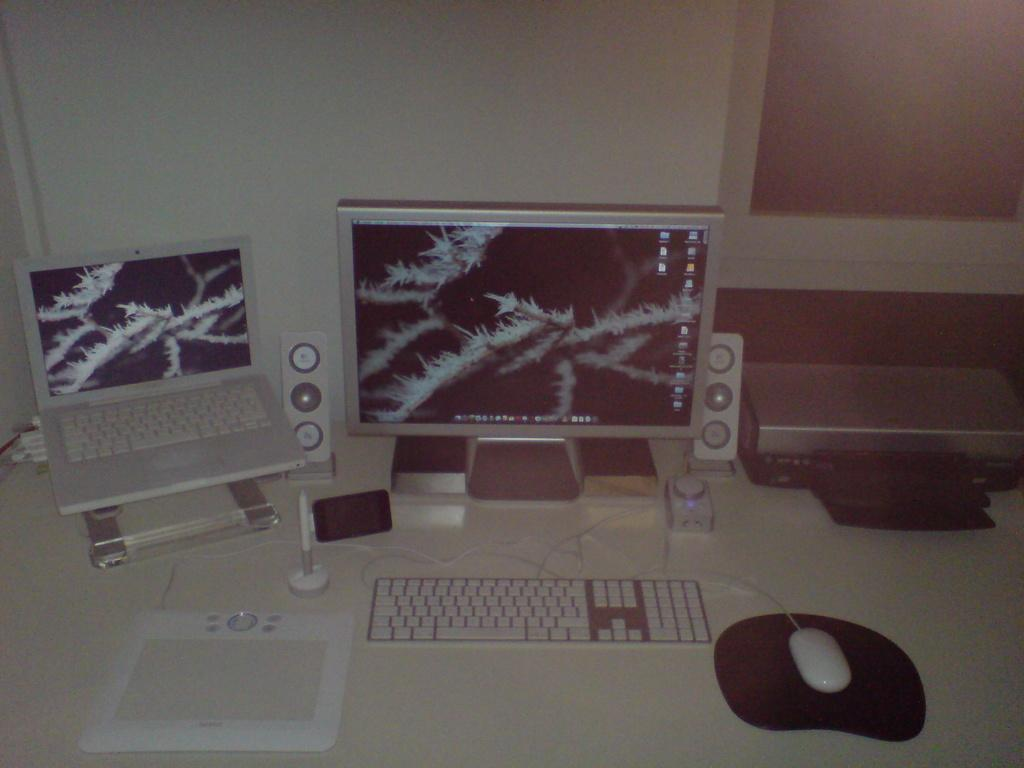What type of electronic device is visible in the image? There is a monitor in the image. What other electronic device can be seen in the image? There is a laptop in the image. What is used for typing in the image? There is a keyboard in the image. What is used for controlling the cursor on the monitor in the image? There is a mouse in the image. What other gadgets are present in the image? There are other gadgets in the image. What time of day is it in the image, and what type of toothpaste is being used? The time of day is not mentioned in the image, and there is no toothpaste present in the image. What industry is represented by the gadgets in the image? The image does not represent any specific industry; it simply shows various electronic devices and gadgets. 